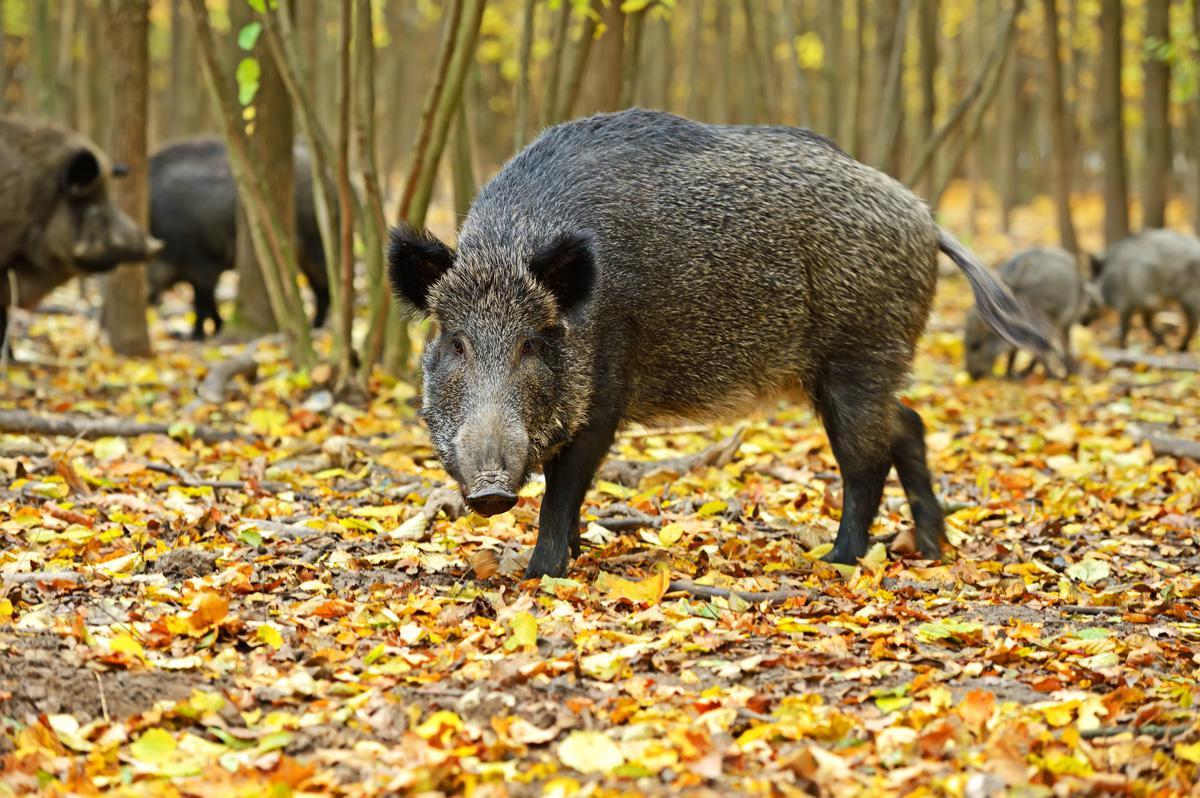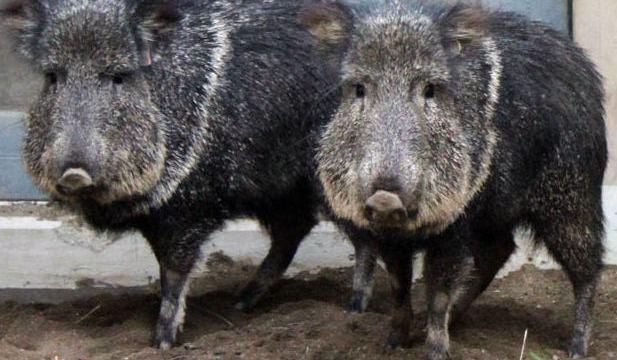The first image is the image on the left, the second image is the image on the right. Evaluate the accuracy of this statement regarding the images: "The pigs are standing on yellow leaves in one image and not in the other.". Is it true? Answer yes or no. Yes. The first image is the image on the left, the second image is the image on the right. Examine the images to the left and right. Is the description "In one image, the animals are standing on grass that is green." accurate? Answer yes or no. No. 